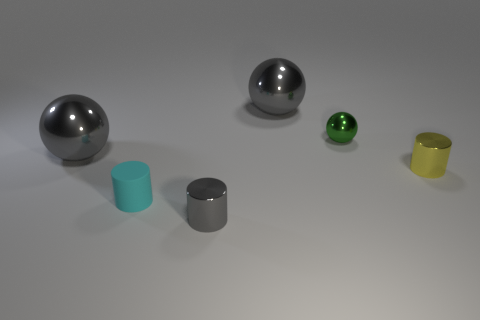Could you describe the texture and condition of the surfaces these objects are resting on? The surfaces on which these objects are resting seem to be smooth and flawless, with a subtle texture that suggests either a synthetic material or a finely polished finish. The condition appears pristine, without any visible blemishes or imperfections. 